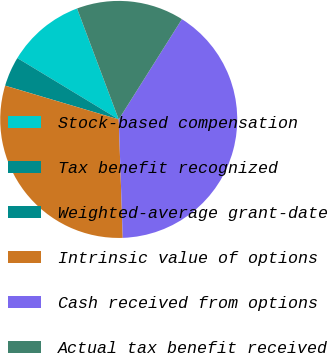Convert chart. <chart><loc_0><loc_0><loc_500><loc_500><pie_chart><fcel>Stock-based compensation<fcel>Tax benefit recognized<fcel>Weighted-average grant-date<fcel>Intrinsic value of options<fcel>Cash received from options<fcel>Actual tax benefit received<nl><fcel>10.62%<fcel>4.06%<fcel>0.01%<fcel>30.14%<fcel>40.51%<fcel>14.67%<nl></chart> 